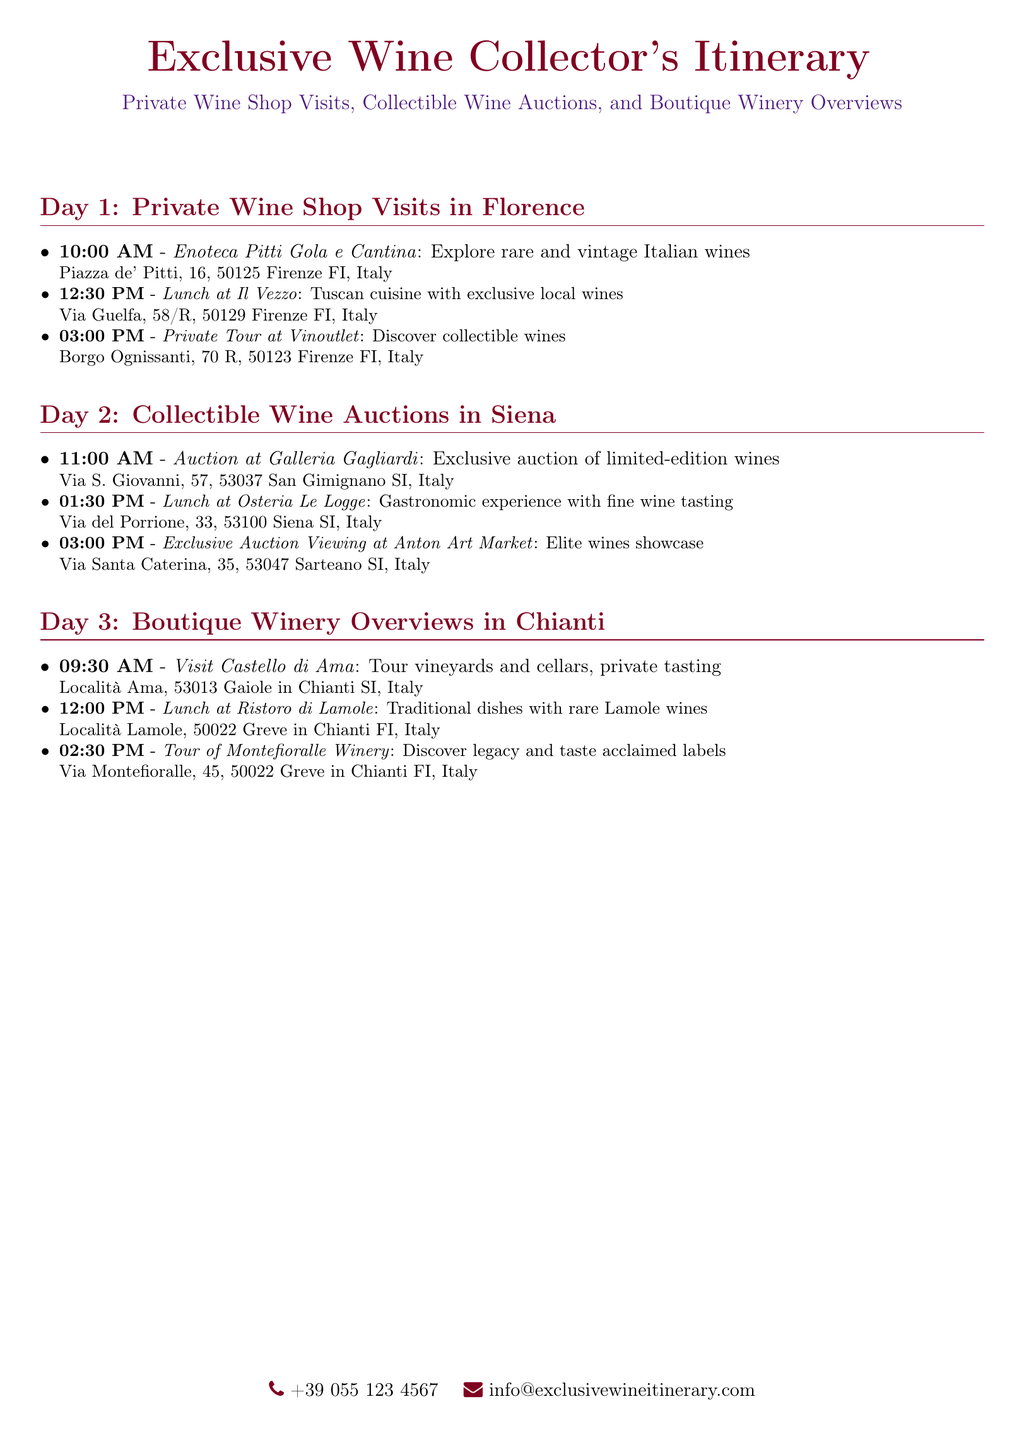What is the starting time for the Private Tour at Vinoutlet? The starting time for the Private Tour at Vinoutlet is mentioned in the itinerary as 03:00 PM.
Answer: 03:00 PM What is the address of Enoteca Pitti Gola e Cantina? The address for Enoteca Pitti Gola e Cantina is provided as Piazza de' Pitti, 16, 50125 Firenze FI, Italy.
Answer: Piazza de' Pitti, 16, 50125 Firenze FI, Italy What type of cuisine is served at Il Vezzo? The type of cuisine served at Il Vezzo is described as Tuscan cuisine with exclusive local wines.
Answer: Tuscan cuisine with exclusive local wines How many locations are mentioned for Day 2? The number of locations mentioned for Day 2 includes the auction and lunch, making a total of three distinct locations.
Answer: Three What time does the auction at Galleria Gagliardi start? The starting time for the auction at Galleria Gagliardi is provided as 11:00 AM in the itinerary.
Answer: 11:00 AM Which winery offers a private tasting experience? The winery that offers a private tasting experience is Castello di Ama, according to the schedule.
Answer: Castello di Ama What is the last event listed on Day 3? The last event listed on Day 3 is the Tour of Montefioralle Winery, which ends the day's itinerary.
Answer: Tour of Montefioralle Winery How many meals are scheduled in the itinerary? The number of meals scheduled in the itinerary totals three, one for each day.
Answer: Three What is the focus of Day 1 of the itinerary? Day 1 focuses on private wine shop visits in Florence, as outlined in the itinerary.
Answer: Private wine shop visits in Florence 